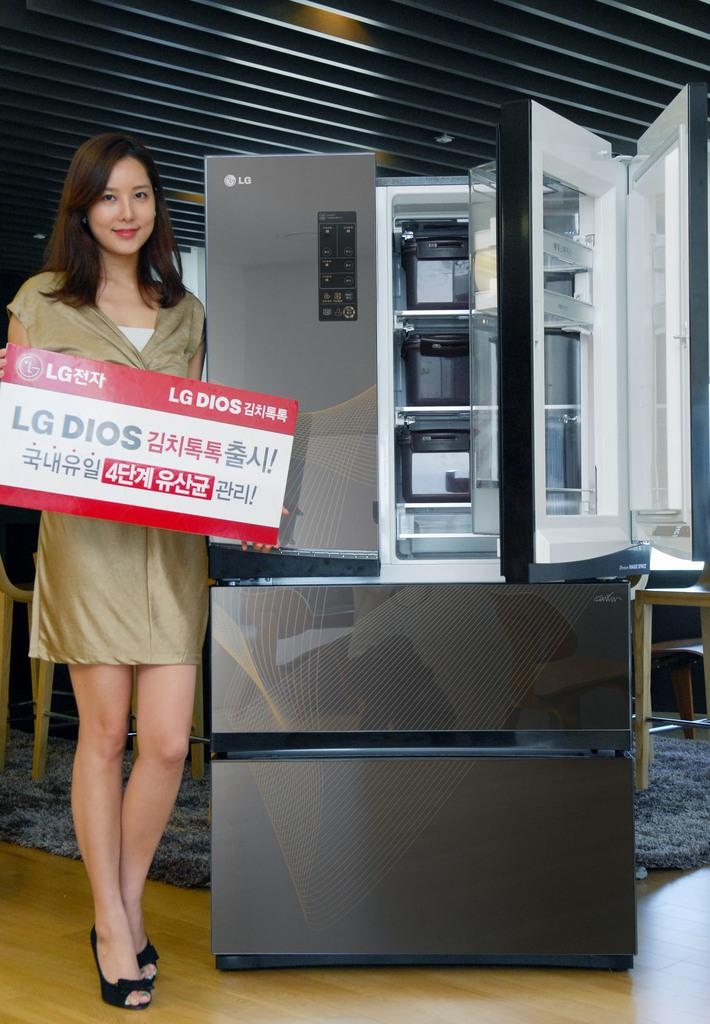<image>
Share a concise interpretation of the image provided. A female model holding a sign with LG DIOS on it 